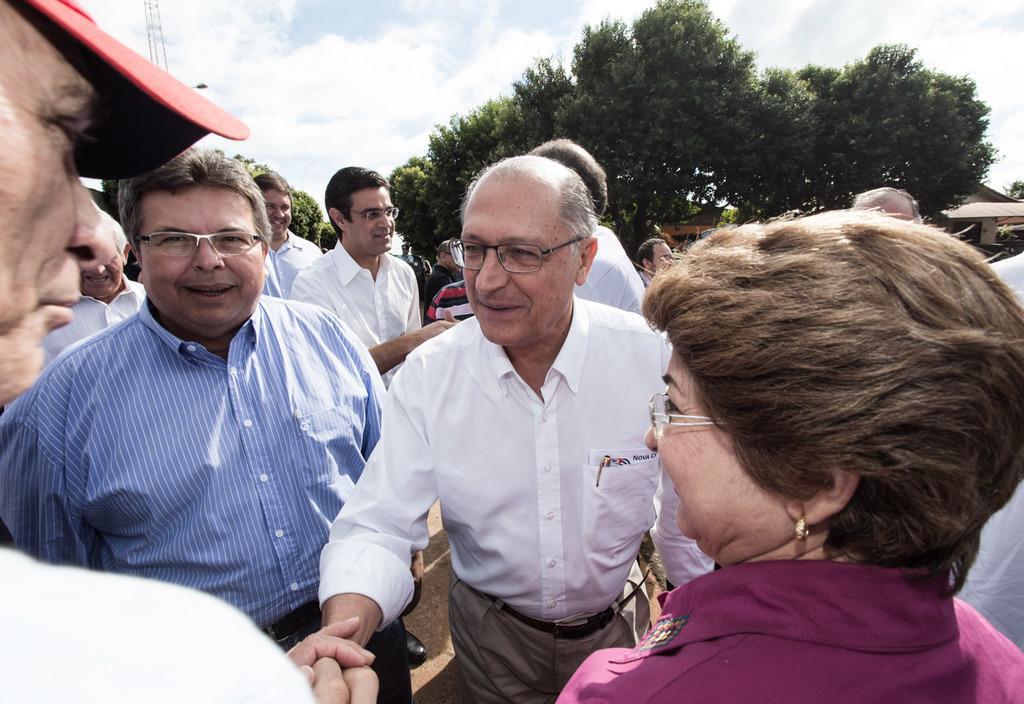Could you give a brief overview of what you see in this image? In the image there are many men standing on the land, on the right side there is a woman, in the back there are trees and above its sky with clouds. 